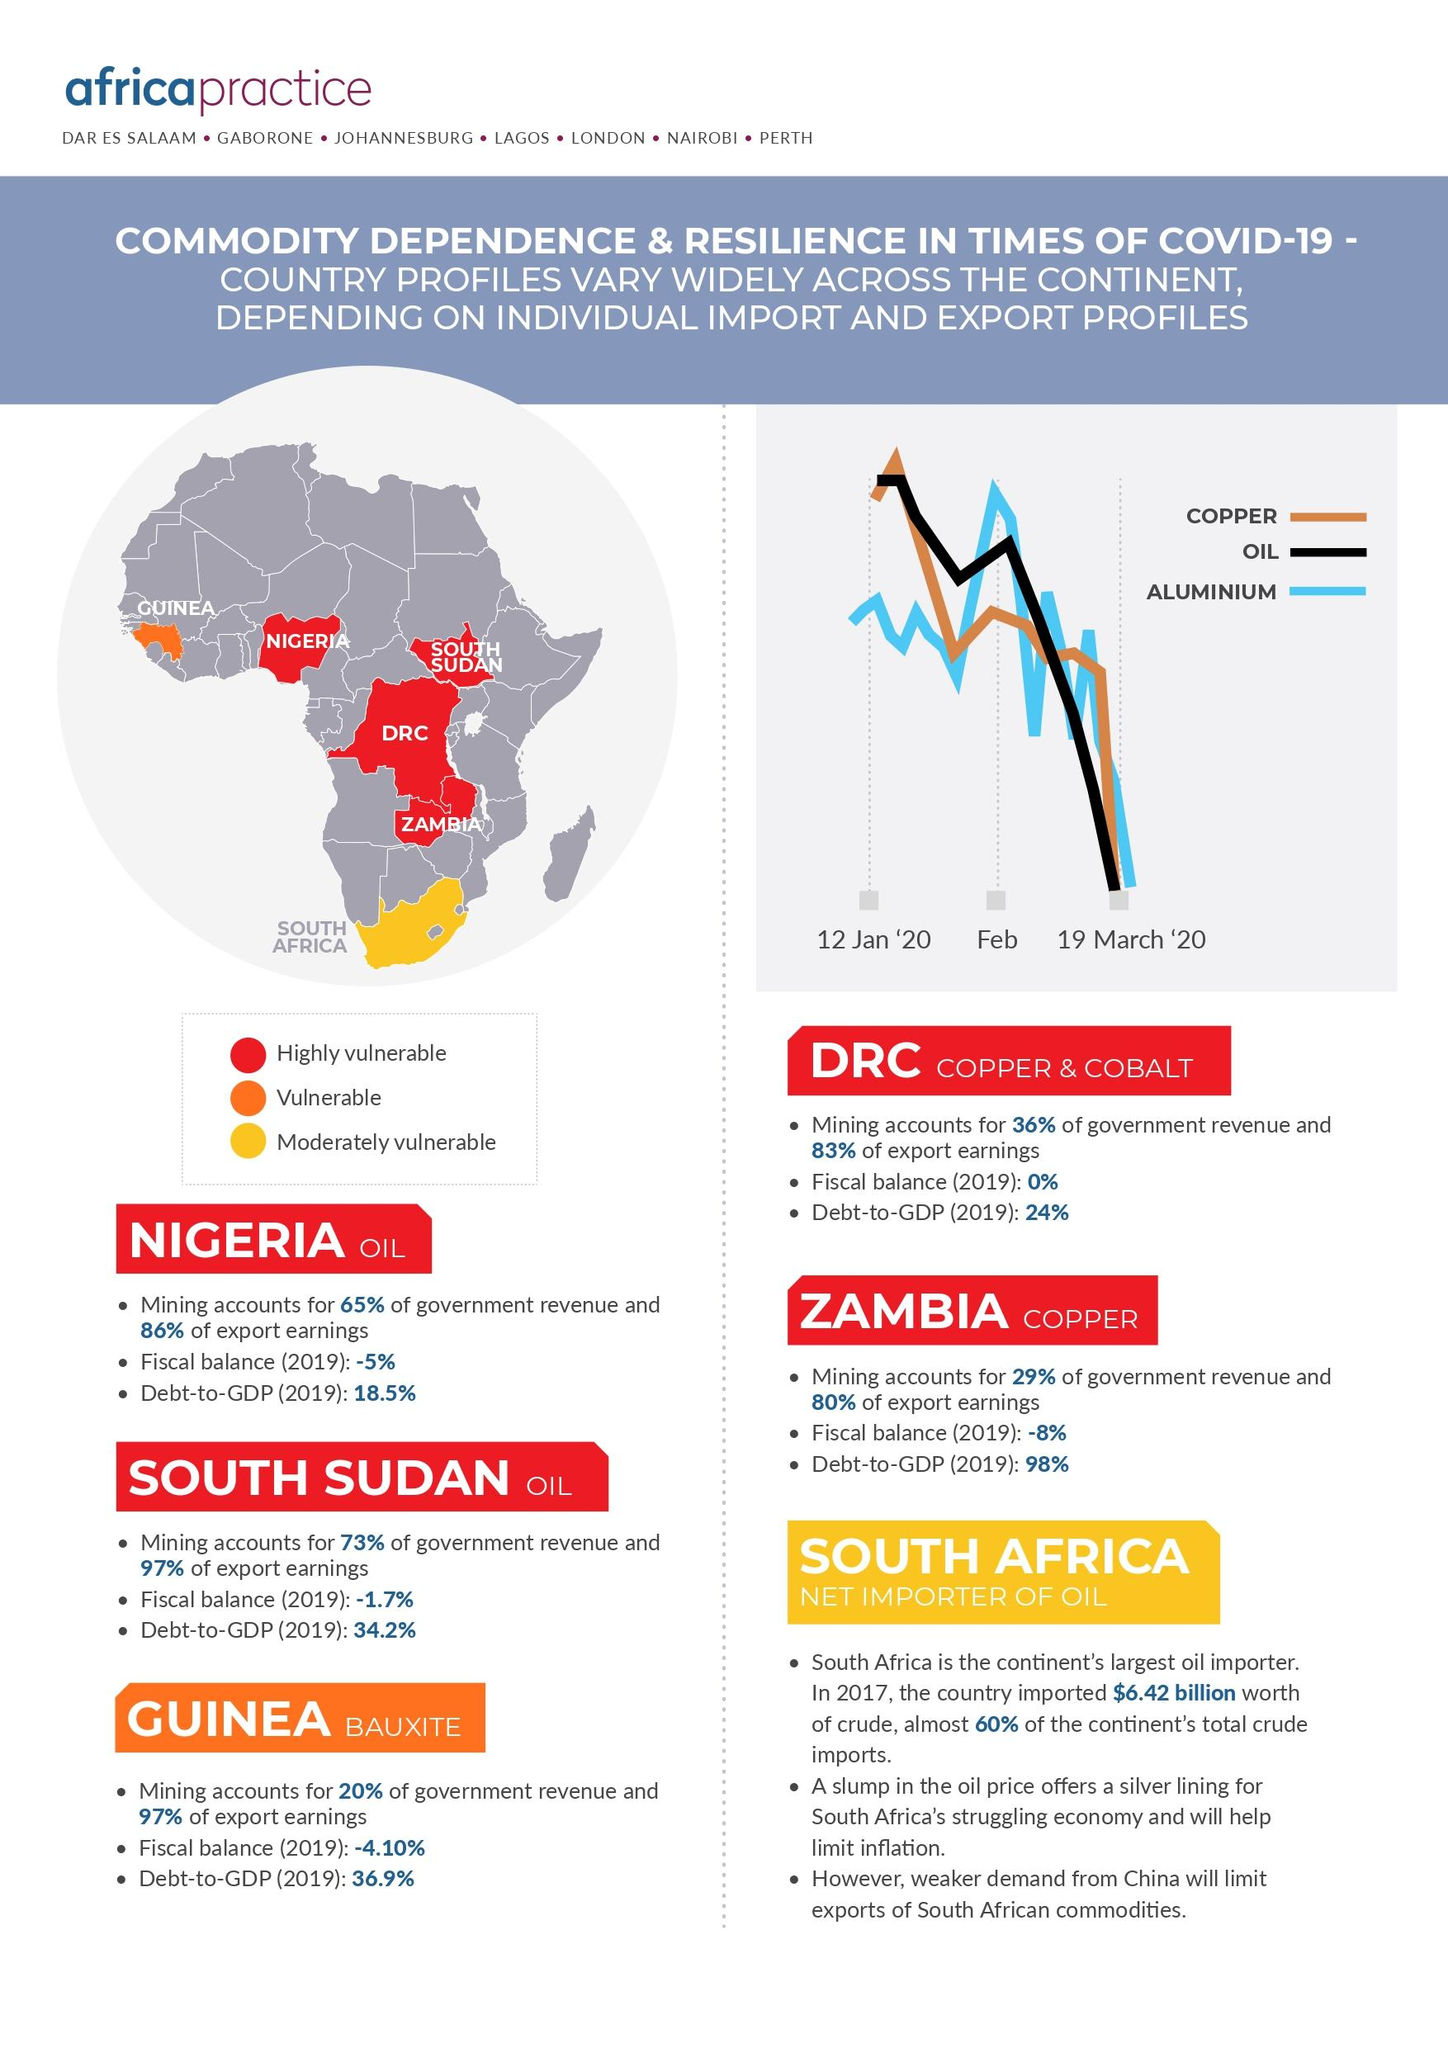Specify some key components in this picture. The government revenue in South Sudan, one of the oil exporting countries, is higher than in the other oil exporting countries. There are 1 or more countries classified as vulnerable. Guinea is classified as vulnerable among the West African countries. The countries that export oil are Nigeria and South Sudan. It is predicted that the economy of South Africa will benefit from a decrease in the price of oil. 